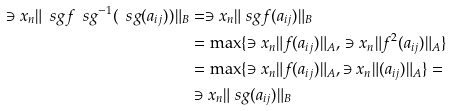Convert formula to latex. <formula><loc_0><loc_0><loc_500><loc_500>\ni x _ { n } \| \ s g f \ s g ^ { - 1 } ( \ s g ( a _ { i j } ) ) \| _ { B } & = \ni x _ { n } \| \ s g f ( a _ { i j } ) \| _ { B } \\ & = \max \{ \ni x _ { n } \| f ( a _ { i j } ) \| _ { A } , \, \ni x _ { n } \| f ^ { 2 } ( a _ { i j } ) \| _ { A } \} \\ & = \max \{ \ni x _ { n } \| f ( a _ { i j } ) \| _ { A } , \ni x _ { n } \| ( a _ { i j } ) \| _ { A } \} = \\ & \ni x _ { n } \| \ s g ( a _ { i j } ) \| _ { B }</formula> 